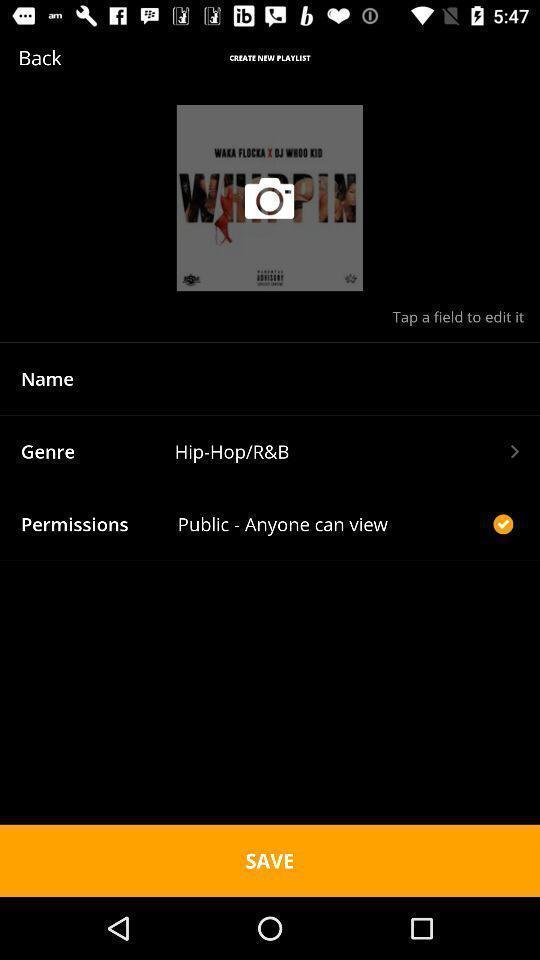Provide a description of this screenshot. Page showing the profile details. 